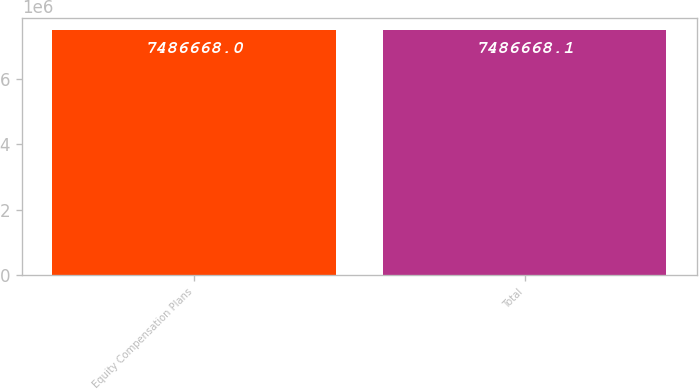Convert chart to OTSL. <chart><loc_0><loc_0><loc_500><loc_500><bar_chart><fcel>Equity Compensation Plans<fcel>Total<nl><fcel>7.48667e+06<fcel>7.48667e+06<nl></chart> 